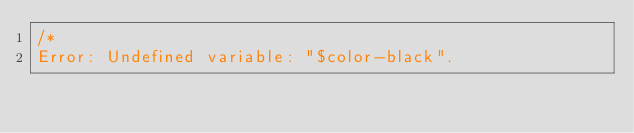Convert code to text. <code><loc_0><loc_0><loc_500><loc_500><_CSS_>/*
Error: Undefined variable: "$color-black".</code> 